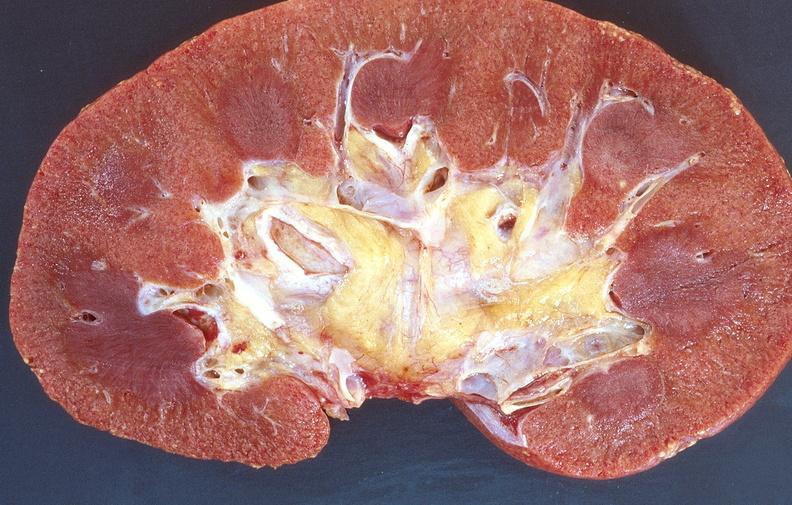does this section show normal kidney?
Answer the question using a single word or phrase. No 